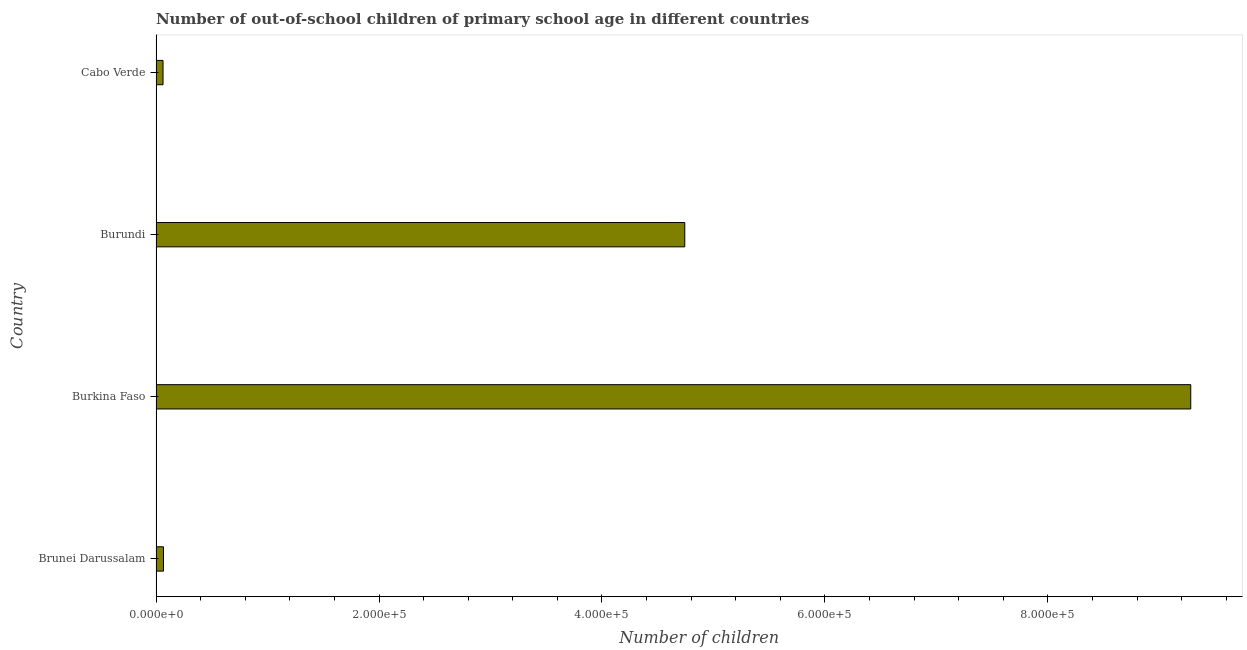Does the graph contain grids?
Your answer should be very brief. No. What is the title of the graph?
Make the answer very short. Number of out-of-school children of primary school age in different countries. What is the label or title of the X-axis?
Offer a terse response. Number of children. What is the label or title of the Y-axis?
Your answer should be compact. Country. What is the number of out-of-school children in Burkina Faso?
Your response must be concise. 9.28e+05. Across all countries, what is the maximum number of out-of-school children?
Give a very brief answer. 9.28e+05. Across all countries, what is the minimum number of out-of-school children?
Make the answer very short. 6291. In which country was the number of out-of-school children maximum?
Offer a terse response. Burkina Faso. In which country was the number of out-of-school children minimum?
Give a very brief answer. Cabo Verde. What is the sum of the number of out-of-school children?
Your answer should be very brief. 1.42e+06. What is the difference between the number of out-of-school children in Brunei Darussalam and Cabo Verde?
Provide a short and direct response. 404. What is the average number of out-of-school children per country?
Provide a succinct answer. 3.54e+05. What is the median number of out-of-school children?
Make the answer very short. 2.40e+05. In how many countries, is the number of out-of-school children greater than 320000 ?
Your answer should be very brief. 2. What is the ratio of the number of out-of-school children in Brunei Darussalam to that in Burundi?
Provide a succinct answer. 0.01. What is the difference between the highest and the second highest number of out-of-school children?
Provide a succinct answer. 4.54e+05. What is the difference between the highest and the lowest number of out-of-school children?
Give a very brief answer. 9.22e+05. What is the difference between two consecutive major ticks on the X-axis?
Ensure brevity in your answer.  2.00e+05. Are the values on the major ticks of X-axis written in scientific E-notation?
Your answer should be compact. Yes. What is the Number of children in Brunei Darussalam?
Ensure brevity in your answer.  6695. What is the Number of children in Burkina Faso?
Provide a succinct answer. 9.28e+05. What is the Number of children in Burundi?
Offer a very short reply. 4.74e+05. What is the Number of children of Cabo Verde?
Make the answer very short. 6291. What is the difference between the Number of children in Brunei Darussalam and Burkina Faso?
Your answer should be compact. -9.21e+05. What is the difference between the Number of children in Brunei Darussalam and Burundi?
Offer a very short reply. -4.68e+05. What is the difference between the Number of children in Brunei Darussalam and Cabo Verde?
Provide a succinct answer. 404. What is the difference between the Number of children in Burkina Faso and Burundi?
Give a very brief answer. 4.54e+05. What is the difference between the Number of children in Burkina Faso and Cabo Verde?
Make the answer very short. 9.22e+05. What is the difference between the Number of children in Burundi and Cabo Verde?
Your answer should be compact. 4.68e+05. What is the ratio of the Number of children in Brunei Darussalam to that in Burkina Faso?
Give a very brief answer. 0.01. What is the ratio of the Number of children in Brunei Darussalam to that in Burundi?
Offer a very short reply. 0.01. What is the ratio of the Number of children in Brunei Darussalam to that in Cabo Verde?
Give a very brief answer. 1.06. What is the ratio of the Number of children in Burkina Faso to that in Burundi?
Make the answer very short. 1.96. What is the ratio of the Number of children in Burkina Faso to that in Cabo Verde?
Keep it short and to the point. 147.53. What is the ratio of the Number of children in Burundi to that in Cabo Verde?
Offer a terse response. 75.38. 